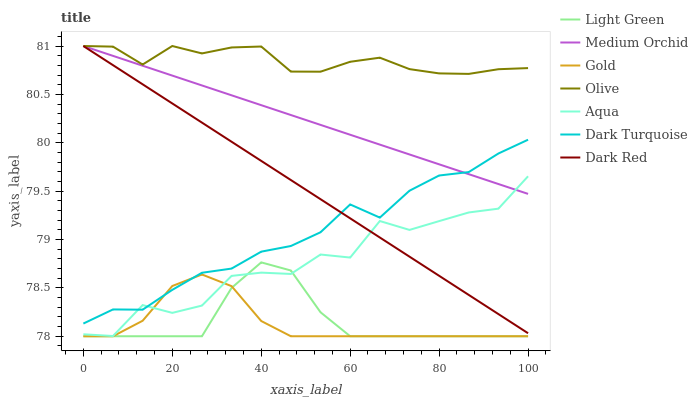Does Gold have the minimum area under the curve?
Answer yes or no. Yes. Does Olive have the maximum area under the curve?
Answer yes or no. Yes. Does Dark Turquoise have the minimum area under the curve?
Answer yes or no. No. Does Dark Turquoise have the maximum area under the curve?
Answer yes or no. No. Is Medium Orchid the smoothest?
Answer yes or no. Yes. Is Aqua the roughest?
Answer yes or no. Yes. Is Dark Turquoise the smoothest?
Answer yes or no. No. Is Dark Turquoise the roughest?
Answer yes or no. No. Does Gold have the lowest value?
Answer yes or no. Yes. Does Dark Turquoise have the lowest value?
Answer yes or no. No. Does Olive have the highest value?
Answer yes or no. Yes. Does Dark Turquoise have the highest value?
Answer yes or no. No. Is Aqua less than Olive?
Answer yes or no. Yes. Is Dark Red greater than Light Green?
Answer yes or no. Yes. Does Dark Turquoise intersect Gold?
Answer yes or no. Yes. Is Dark Turquoise less than Gold?
Answer yes or no. No. Is Dark Turquoise greater than Gold?
Answer yes or no. No. Does Aqua intersect Olive?
Answer yes or no. No. 